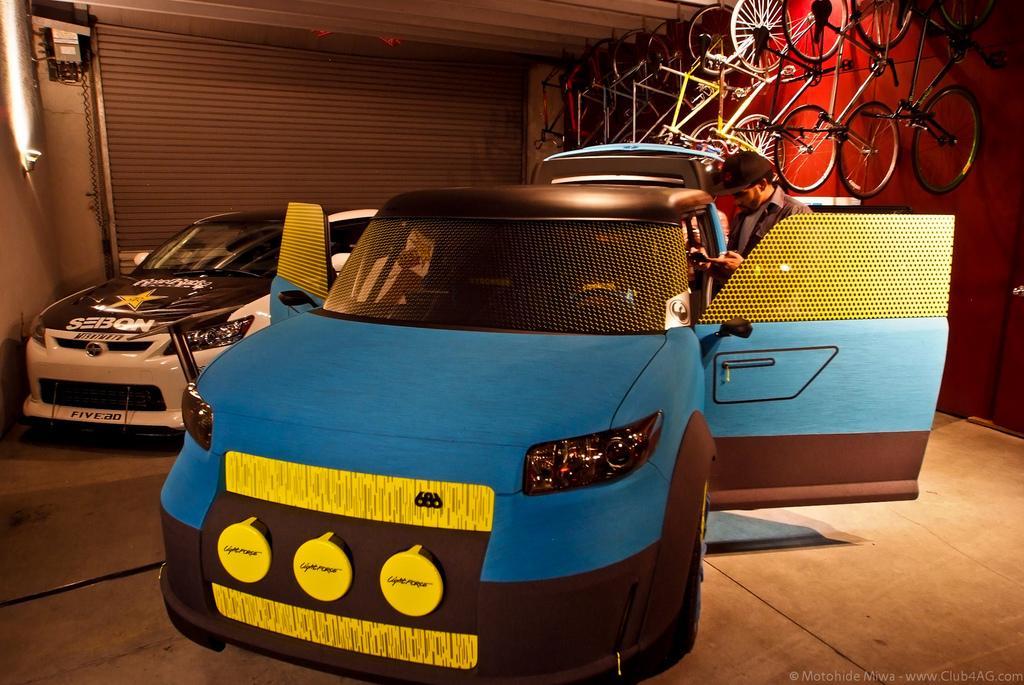Please provide a concise description of this image. In this image I can see two vehicles which are colorful. To the right I can see the person and the bicycles. These are inside the shed. In the background I can see the shutter, pipe and the board to the wall. 